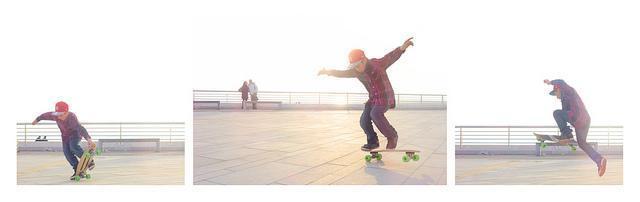How many train cars are behind the locomotive?
Give a very brief answer. 0. 